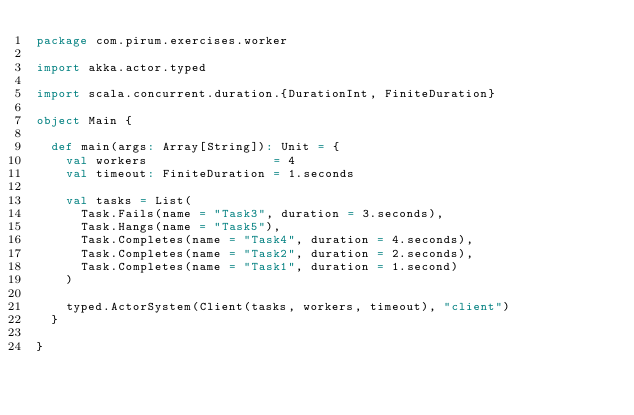<code> <loc_0><loc_0><loc_500><loc_500><_Scala_>package com.pirum.exercises.worker

import akka.actor.typed

import scala.concurrent.duration.{DurationInt, FiniteDuration}

object Main {

  def main(args: Array[String]): Unit = {
    val workers                 = 4
    val timeout: FiniteDuration = 1.seconds
    
    val tasks = List(
      Task.Fails(name = "Task3", duration = 3.seconds),
      Task.Hangs(name = "Task5"),
      Task.Completes(name = "Task4", duration = 4.seconds),
      Task.Completes(name = "Task2", duration = 2.seconds),
      Task.Completes(name = "Task1", duration = 1.second)
    )

    typed.ActorSystem(Client(tasks, workers, timeout), "client")
  }

}
</code> 